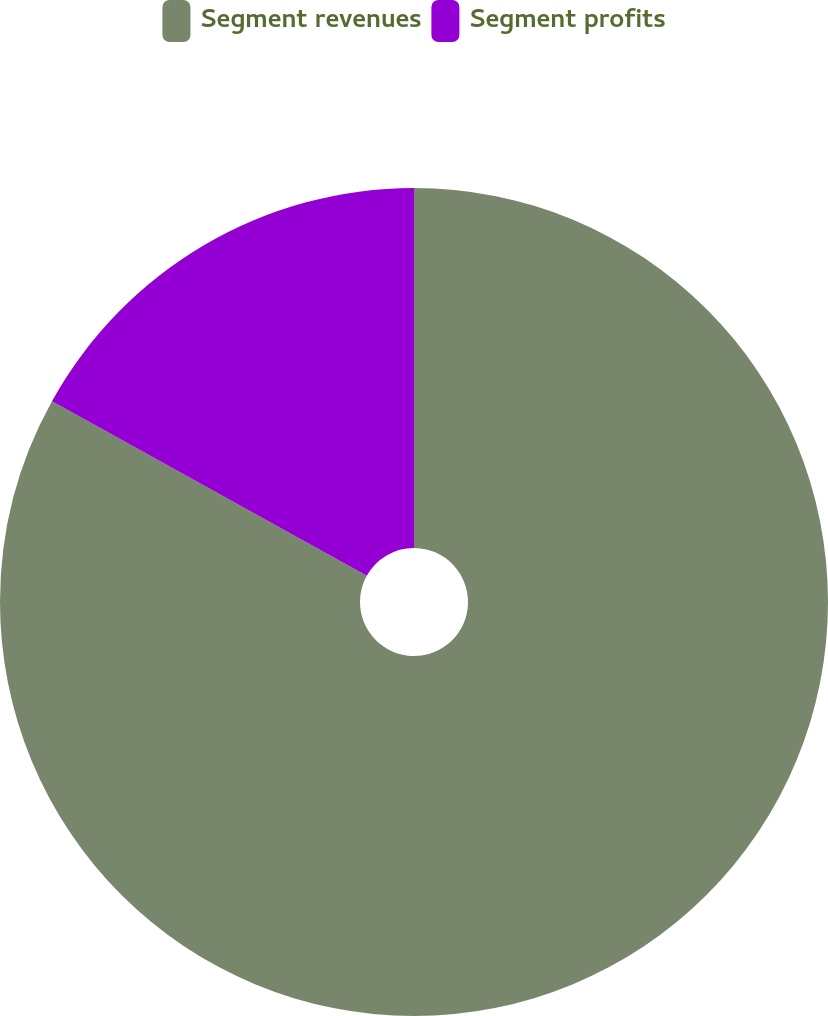Convert chart. <chart><loc_0><loc_0><loc_500><loc_500><pie_chart><fcel>Segment revenues<fcel>Segment profits<nl><fcel>83.06%<fcel>16.94%<nl></chart> 